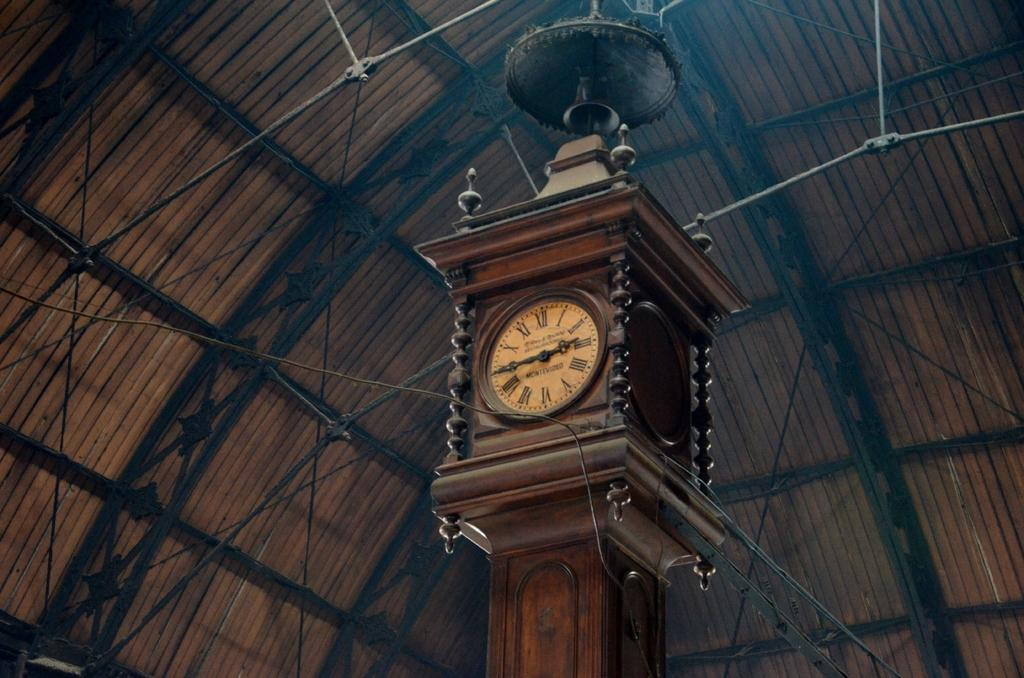<image>
Provide a brief description of the given image. An ornate wood clock by Montevideo reads 2:45 